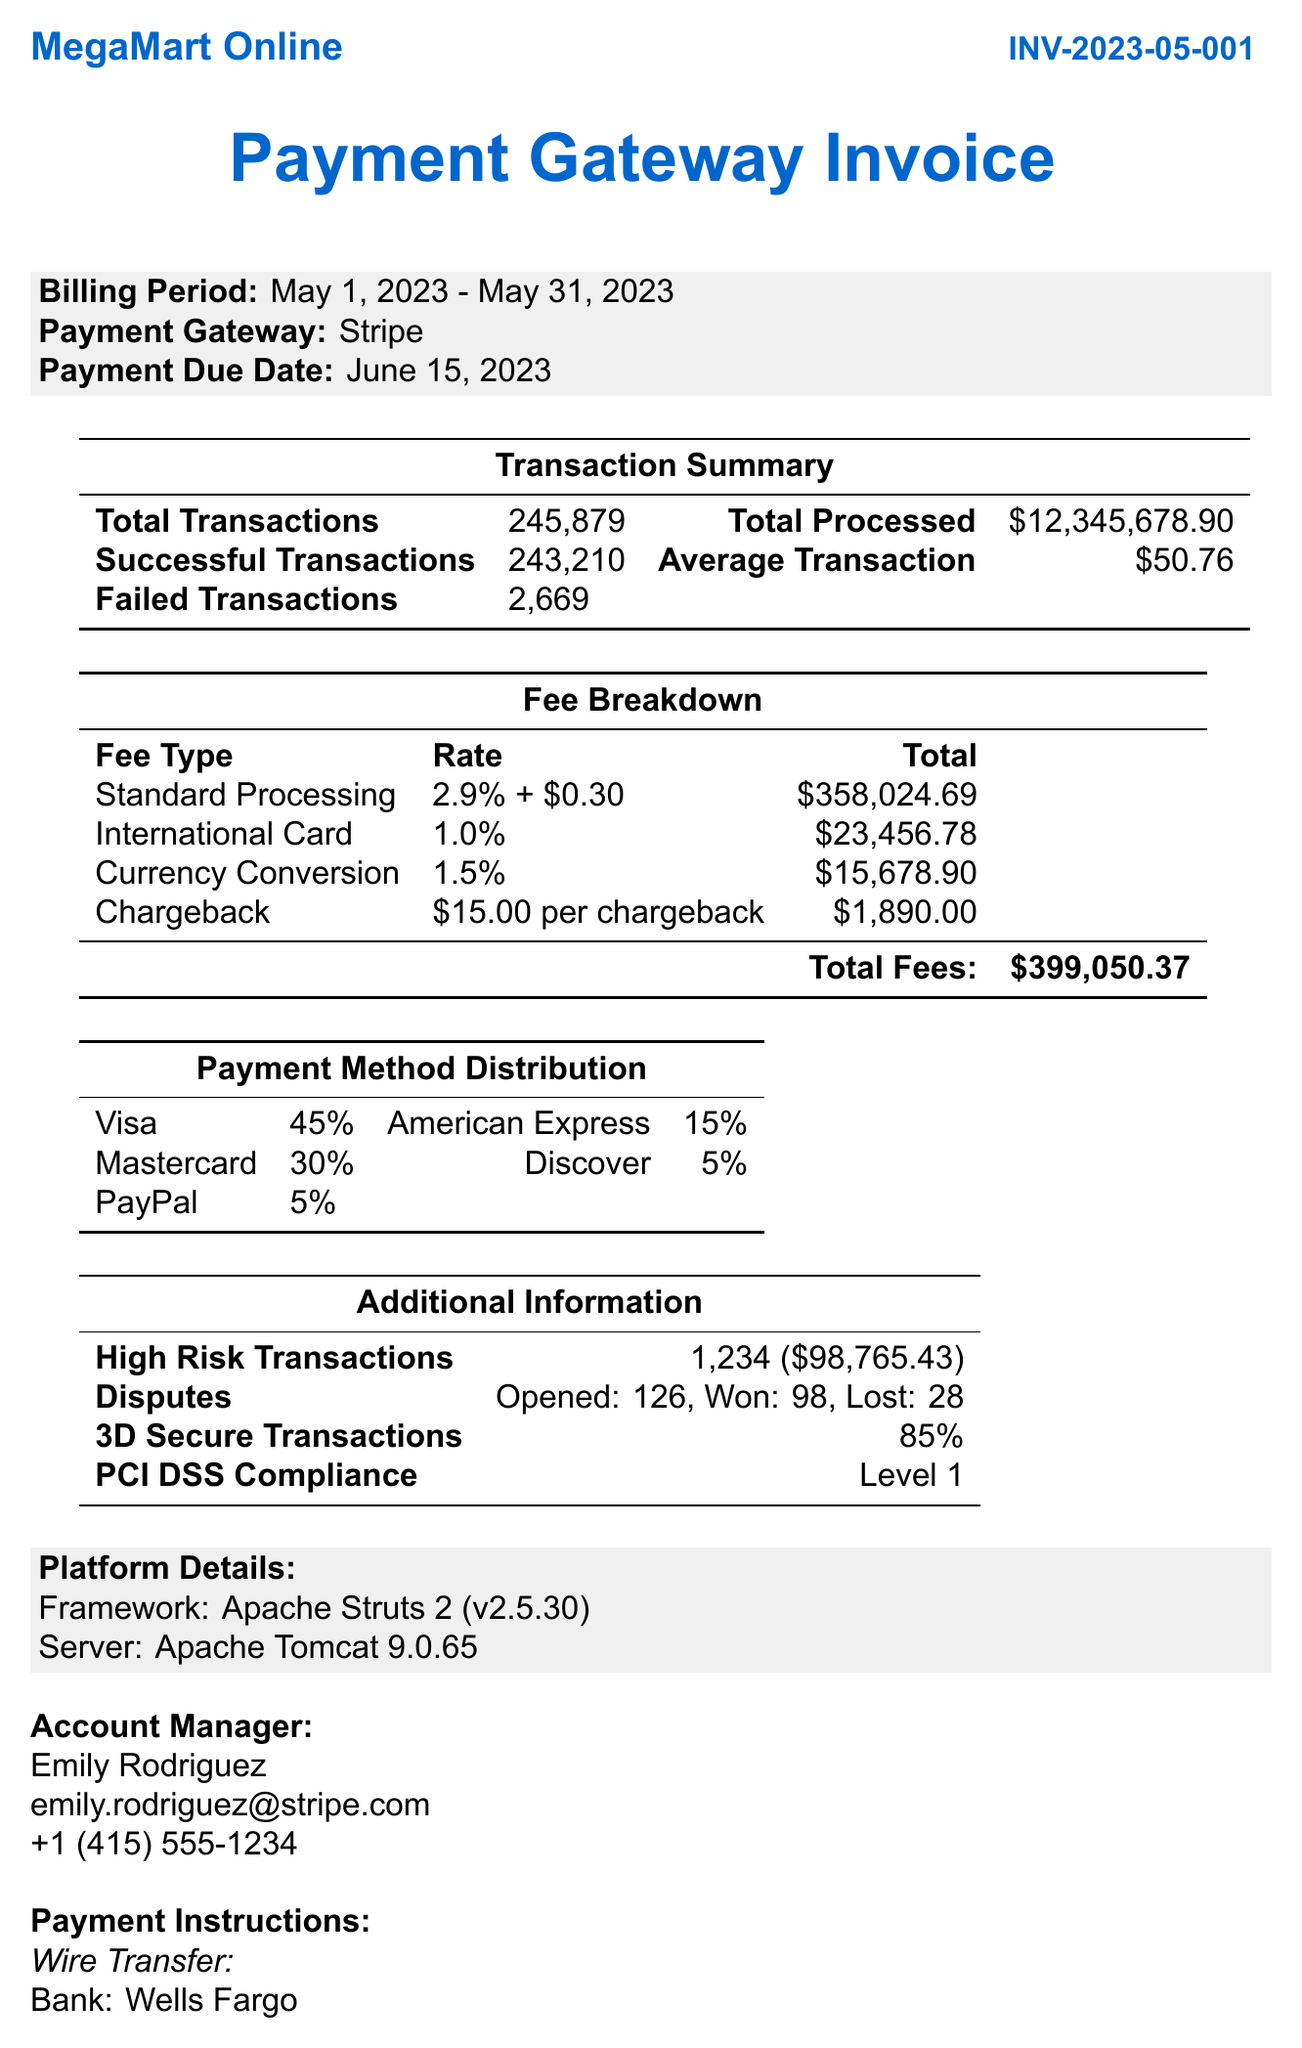What is the invoice number? The invoice number is explicitly stated in the document header as INV-2023-05-001.
Answer: INV-2023-05-001 What is the total number of transactions? The document lists the total number of transactions in the transaction summary section as 245,879.
Answer: 245,879 What is the total fee charged for standard processing? The document specifies the total fee for standard processing in the fee breakdown section as $358,024.69.
Answer: $358,024.69 How many disputes were opened? The document indicates that 126 disputes were opened, as shown in the additional information section.
Answer: 126 What percentage of payment methods are made with PayPal? The payment method distribution section shows that PayPal accounts for 5% of transactions.
Answer: 5% What is the payment due date? The payment due date is provided in the billing information section of the document as June 15, 2023.
Answer: June 15, 2023 How many successful transactions were there? The document records 243,210 successful transactions in the transaction summary.
Answer: 243,210 What is the average transaction value? The average transaction value is displayed in the transaction summary as $50.76.
Answer: $50.76 What is the name of the account manager? The document states the account manager's name as Emily Rodriguez.
Answer: Emily Rodriguez 